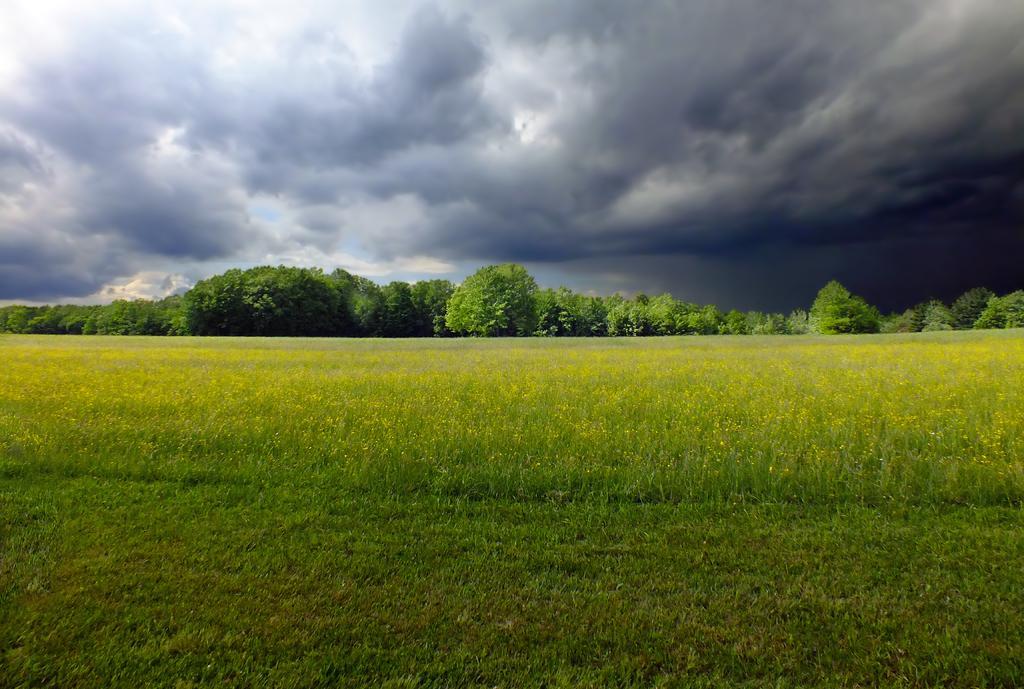In one or two sentences, can you explain what this image depicts? As we can see in the image there are plants, grass and trees. At the top there is sky and clouds. 